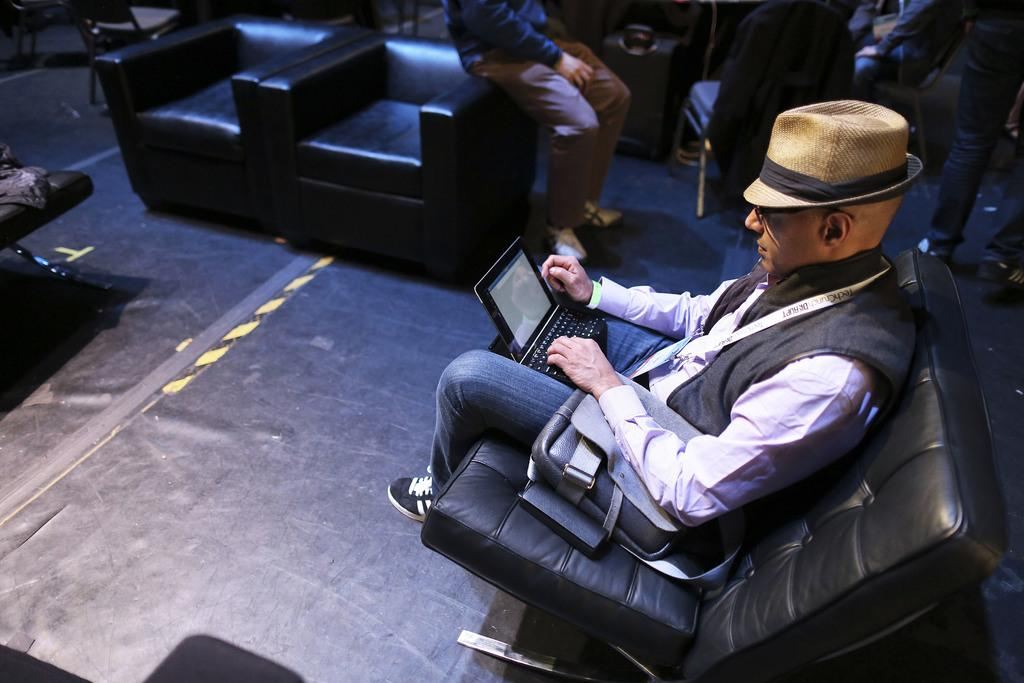Who is present in the image? There is a man in the image. What is the man doing in the image? The man is seated on a sofa. What accessories is the man wearing in the image? The man is wearing a cap on his head and sunglasses on his face. What type of bear can be seen playing with the man's cap in the image? There is no bear present in the image, and the man's cap is not being played with by any animal. 